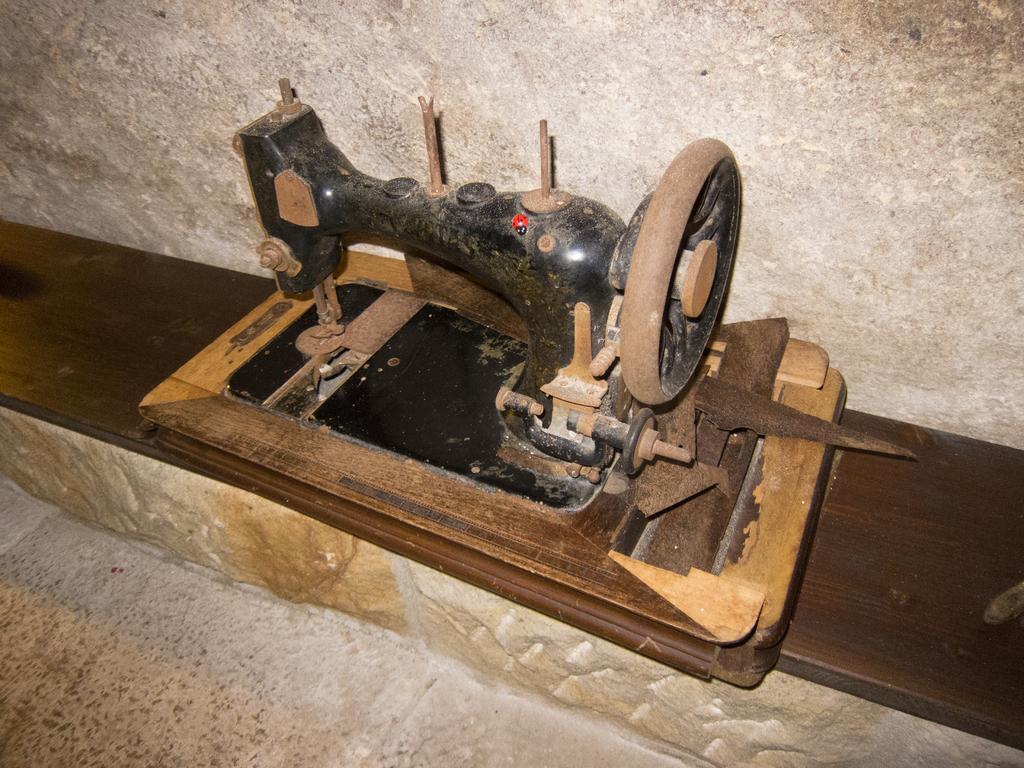How would you summarize this image in a sentence or two? In this image there is a sewing machine on the wooden plank which is on the rock. Background there is a wall. Bottom of the image there is a floor. 